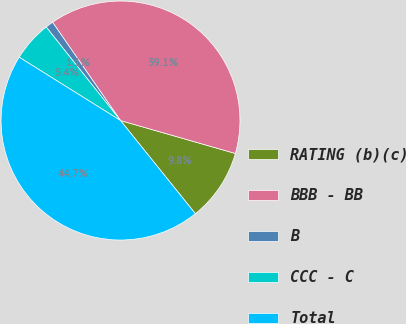Convert chart to OTSL. <chart><loc_0><loc_0><loc_500><loc_500><pie_chart><fcel>RATING (b)(c)<fcel>BBB - BB<fcel>B<fcel>CCC - C<fcel>Total<nl><fcel>9.78%<fcel>39.07%<fcel>1.06%<fcel>5.42%<fcel>44.67%<nl></chart> 